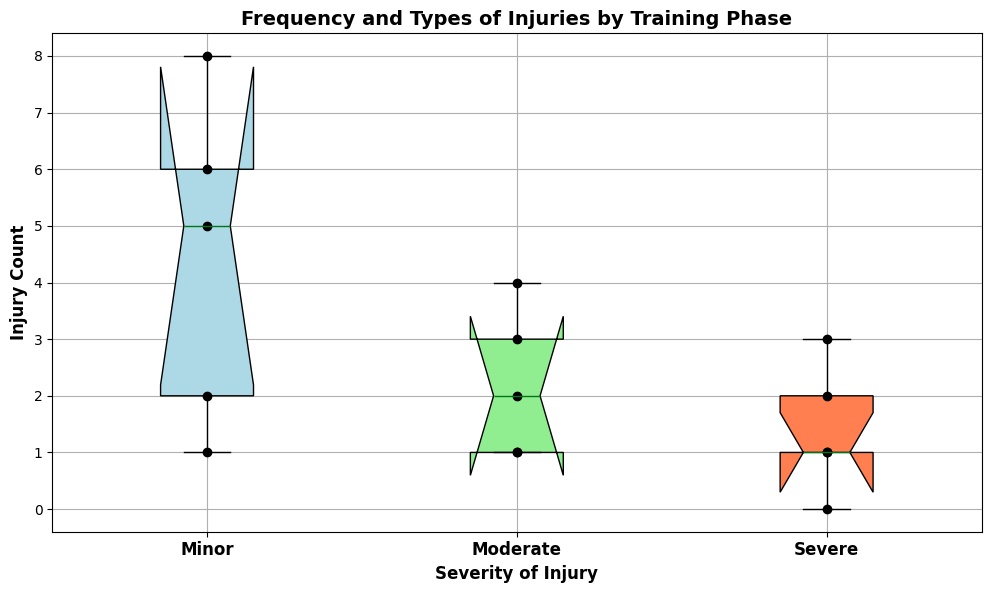Which training phase had the highest count of minor injuries? To determine this, look at the scatter points for "Minor" injuries and identify the phase with the highest points. The "Build" phase shows the highest count with 8 minor injuries.
Answer: Build What is the median count of moderate injuries? The median is the middle value of a dataset. For moderate injuries, the counts are [2, 3, 4, 1, 1]. When sorted, they become [1, 1, 2, 3, 4], so the median value is the middle one, which is 2.
Answer: 2 How many severe injuries were recorded during the Recovery phase? Look at the scatter points for the "Severe" injuries category. The point for the Recovery phase is at 0.
Answer: 0 Compare the total number of injuries during the Base and Peak training phases. Which one has more? The Base phase has counts [5, 2, 1] summing to 8. The Peak phase has counts [6, 4, 3] summing to 13. The Peak phase has more injuries.
Answer: Peak Which severity level of injuries tends to have the lowest frequency? By examining the box plots, the heights of the boxes representing severe injuries seem consistently lower than those for minor or moderate injuries, indicating lower frequencies.
Answer: Severe What is the interquartile range (IQR) for minor injuries? The IQR is the difference between the 75th percentile and the 25th percentile. For minor injuries, locate the edges of the box in the "Minor" category. Approximating from the figure, the IQR is 5 to 6, so 6 - 5 = 1.
Answer: 1 Which severity level has the widest spread in injury counts? The spread of a box plot is indicated by the range from the lowest point to the highest point including whiskers. The "Moderate" severity has a wider range from 1 to 4.
Answer: Moderate How many moderate injuries were reported during the Competition phase? Check the scatter points for the "Moderate" severity; the Competition phase shows a value point at 1.
Answer: 1 Is the average count of severe injuries during the Base and Build phases higher than the median count of moderate injuries? The count of severe injuries in Base and Build are [1, 2], the average is (1+2)/2 = 1.5. The median of moderate injuries is 2, so 1.5 < 2, meaning the average is not higher.
Answer: No What is the range of severe injuries during the Peak phase? Look at the scatter points for severe injuries during the Peak phase; they range from 3. Since there's only one value, the range is 0.
Answer: 0 